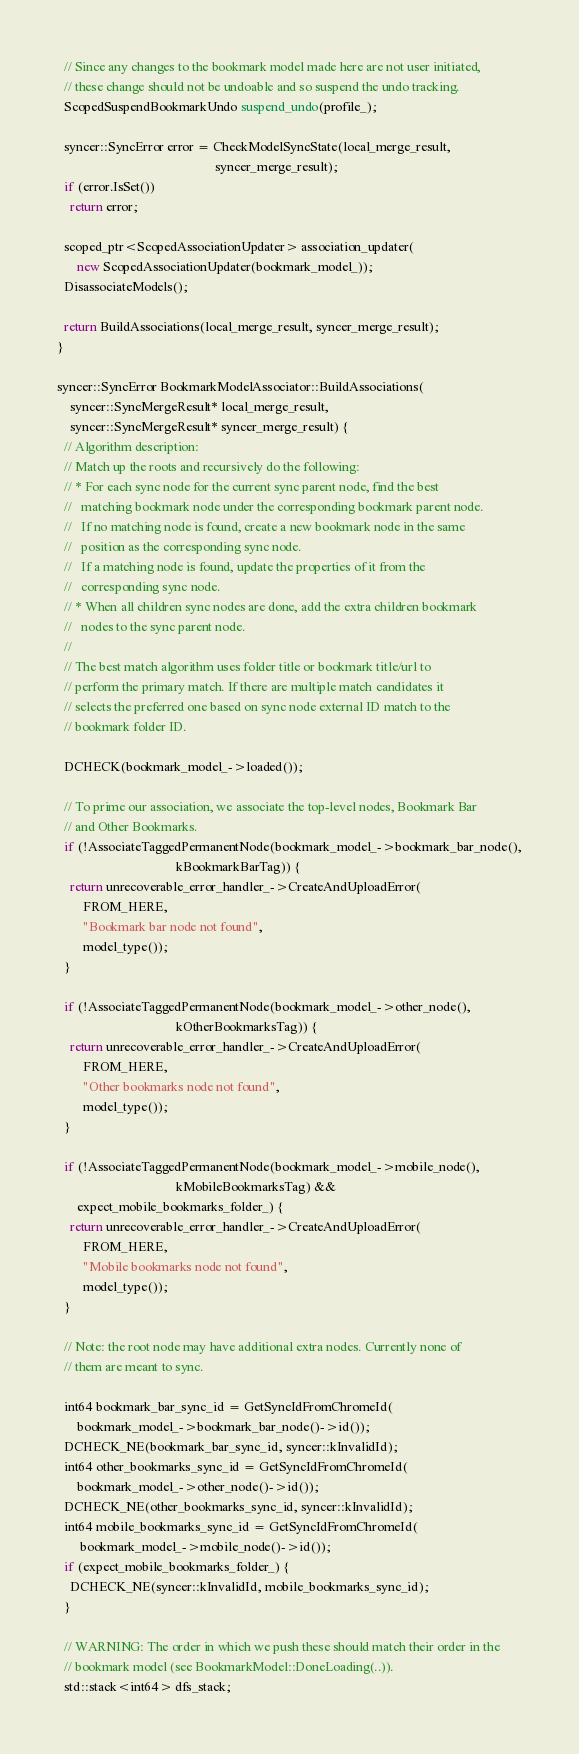<code> <loc_0><loc_0><loc_500><loc_500><_C++_>  // Since any changes to the bookmark model made here are not user initiated,
  // these change should not be undoable and so suspend the undo tracking.
  ScopedSuspendBookmarkUndo suspend_undo(profile_);

  syncer::SyncError error = CheckModelSyncState(local_merge_result,
                                                syncer_merge_result);
  if (error.IsSet())
    return error;

  scoped_ptr<ScopedAssociationUpdater> association_updater(
      new ScopedAssociationUpdater(bookmark_model_));
  DisassociateModels();

  return BuildAssociations(local_merge_result, syncer_merge_result);
}

syncer::SyncError BookmarkModelAssociator::BuildAssociations(
    syncer::SyncMergeResult* local_merge_result,
    syncer::SyncMergeResult* syncer_merge_result) {
  // Algorithm description:
  // Match up the roots and recursively do the following:
  // * For each sync node for the current sync parent node, find the best
  //   matching bookmark node under the corresponding bookmark parent node.
  //   If no matching node is found, create a new bookmark node in the same
  //   position as the corresponding sync node.
  //   If a matching node is found, update the properties of it from the
  //   corresponding sync node.
  // * When all children sync nodes are done, add the extra children bookmark
  //   nodes to the sync parent node.
  //
  // The best match algorithm uses folder title or bookmark title/url to
  // perform the primary match. If there are multiple match candidates it
  // selects the preferred one based on sync node external ID match to the
  // bookmark folder ID.

  DCHECK(bookmark_model_->loaded());

  // To prime our association, we associate the top-level nodes, Bookmark Bar
  // and Other Bookmarks.
  if (!AssociateTaggedPermanentNode(bookmark_model_->bookmark_bar_node(),
                                    kBookmarkBarTag)) {
    return unrecoverable_error_handler_->CreateAndUploadError(
        FROM_HERE,
        "Bookmark bar node not found",
        model_type());
  }

  if (!AssociateTaggedPermanentNode(bookmark_model_->other_node(),
                                    kOtherBookmarksTag)) {
    return unrecoverable_error_handler_->CreateAndUploadError(
        FROM_HERE,
        "Other bookmarks node not found",
        model_type());
  }

  if (!AssociateTaggedPermanentNode(bookmark_model_->mobile_node(),
                                    kMobileBookmarksTag) &&
      expect_mobile_bookmarks_folder_) {
    return unrecoverable_error_handler_->CreateAndUploadError(
        FROM_HERE,
        "Mobile bookmarks node not found",
        model_type());
  }

  // Note: the root node may have additional extra nodes. Currently none of
  // them are meant to sync.

  int64 bookmark_bar_sync_id = GetSyncIdFromChromeId(
      bookmark_model_->bookmark_bar_node()->id());
  DCHECK_NE(bookmark_bar_sync_id, syncer::kInvalidId);
  int64 other_bookmarks_sync_id = GetSyncIdFromChromeId(
      bookmark_model_->other_node()->id());
  DCHECK_NE(other_bookmarks_sync_id, syncer::kInvalidId);
  int64 mobile_bookmarks_sync_id = GetSyncIdFromChromeId(
       bookmark_model_->mobile_node()->id());
  if (expect_mobile_bookmarks_folder_) {
    DCHECK_NE(syncer::kInvalidId, mobile_bookmarks_sync_id);
  }

  // WARNING: The order in which we push these should match their order in the
  // bookmark model (see BookmarkModel::DoneLoading(..)).
  std::stack<int64> dfs_stack;</code> 